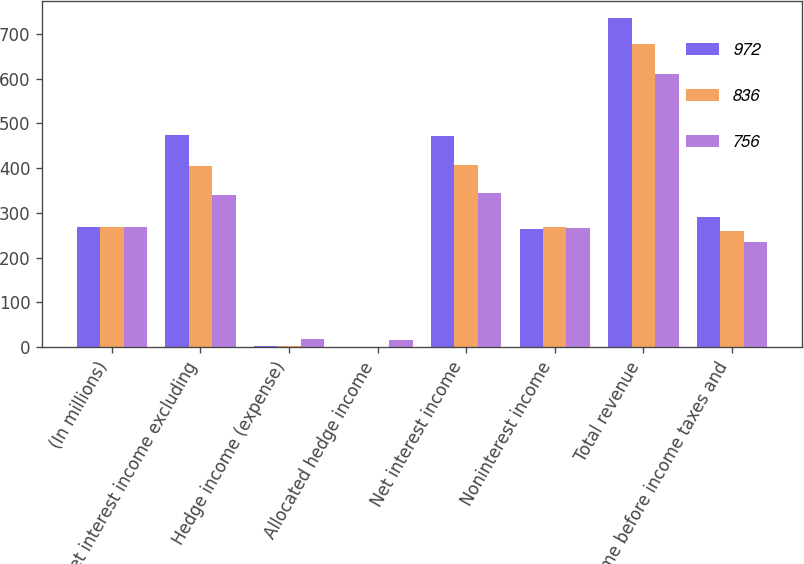Convert chart to OTSL. <chart><loc_0><loc_0><loc_500><loc_500><stacked_bar_chart><ecel><fcel>(In millions)<fcel>Net interest income excluding<fcel>Hedge income (expense)<fcel>Allocated hedge income<fcel>Net interest income<fcel>Noninterest income<fcel>Total revenue<fcel>Income before income taxes and<nl><fcel>972<fcel>269.2<fcel>473.9<fcel>2.2<fcel>0.6<fcel>472.3<fcel>263.7<fcel>736<fcel>290<nl><fcel>836<fcel>269.2<fcel>405.8<fcel>2.3<fcel>0.2<fcel>407.9<fcel>269.2<fcel>677.1<fcel>259.4<nl><fcel>756<fcel>269.2<fcel>340.5<fcel>18.7<fcel>15.4<fcel>343.8<fcel>265.9<fcel>609.7<fcel>234<nl></chart> 